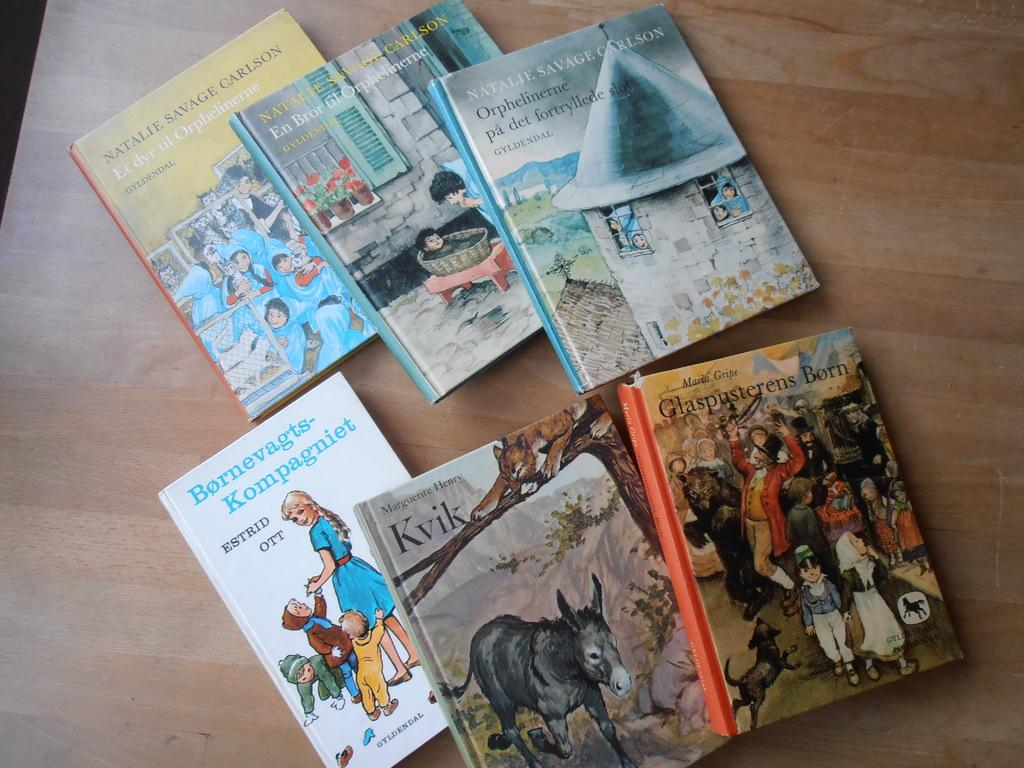Provide a one-sentence caption for the provided image. Six different books are all stacked on a wooden surface with one being Kvik by Marguerite Henry. 